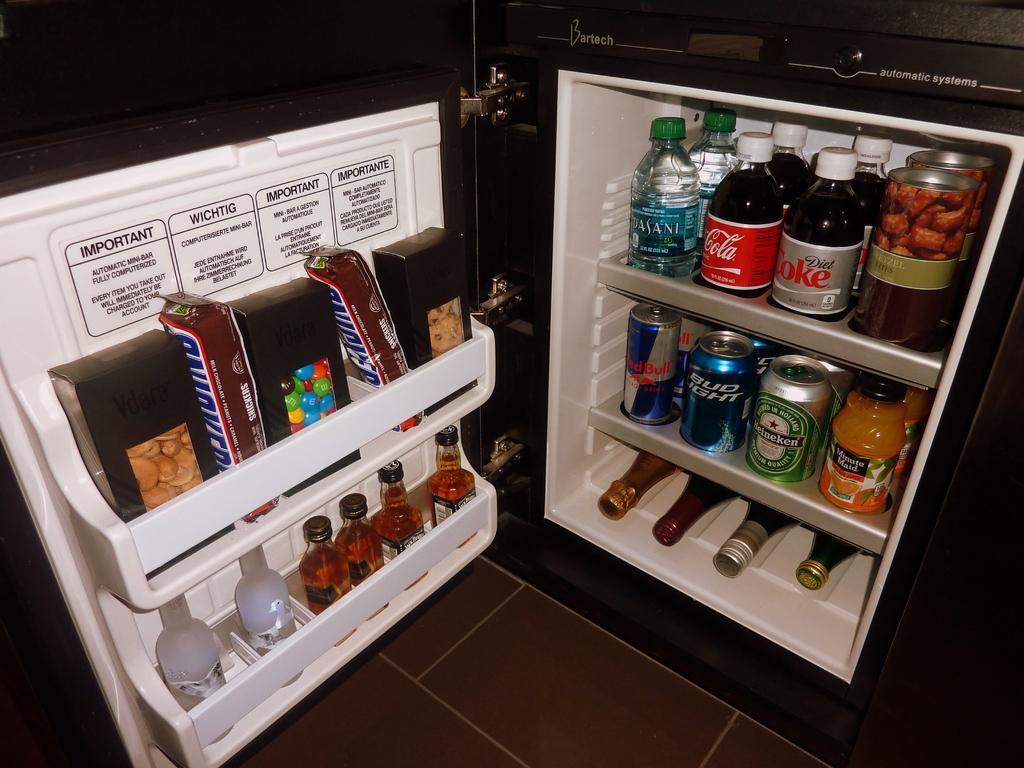Provide a one-sentence caption for the provided image. the refrigerator is full of snickers, soda, beer and wine. 